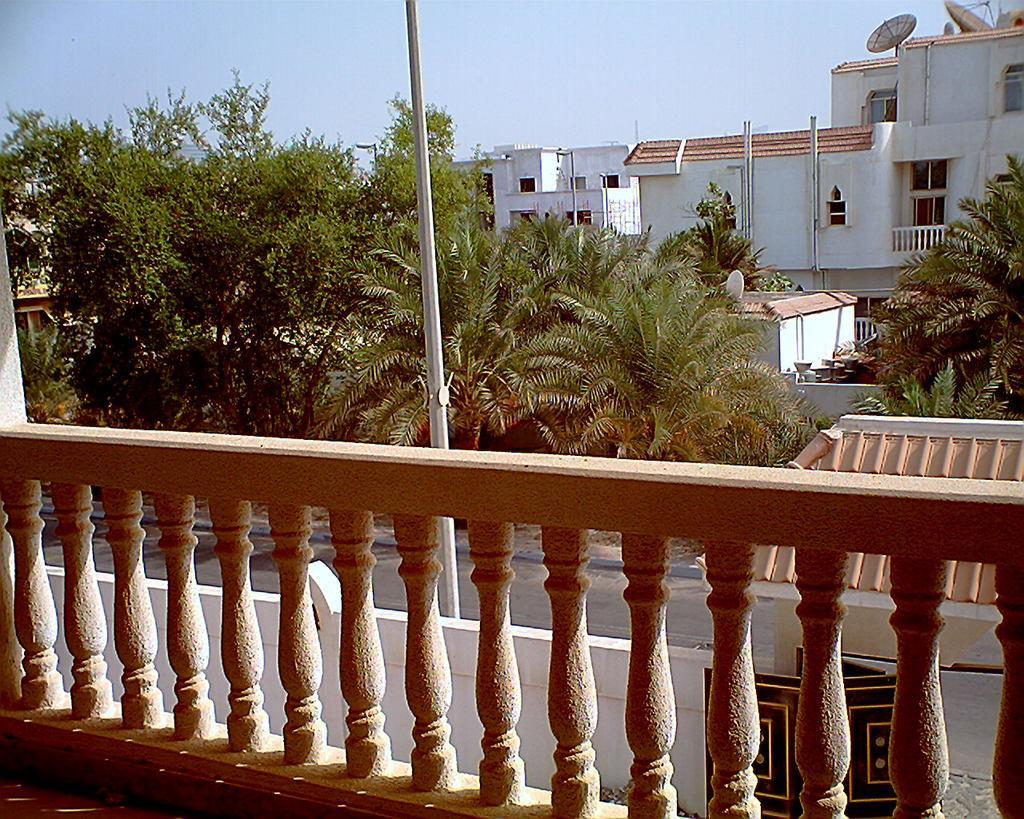Describe this image in one or two sentences. In this picture I can see the railing in front and I see the buildings and trees in the middle of this image and in the background I see the sky. 